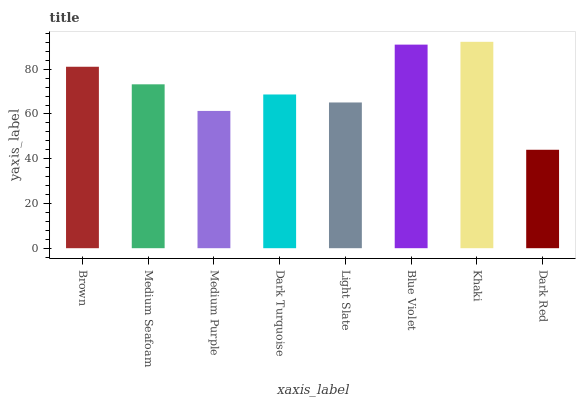Is Dark Red the minimum?
Answer yes or no. Yes. Is Khaki the maximum?
Answer yes or no. Yes. Is Medium Seafoam the minimum?
Answer yes or no. No. Is Medium Seafoam the maximum?
Answer yes or no. No. Is Brown greater than Medium Seafoam?
Answer yes or no. Yes. Is Medium Seafoam less than Brown?
Answer yes or no. Yes. Is Medium Seafoam greater than Brown?
Answer yes or no. No. Is Brown less than Medium Seafoam?
Answer yes or no. No. Is Medium Seafoam the high median?
Answer yes or no. Yes. Is Dark Turquoise the low median?
Answer yes or no. Yes. Is Brown the high median?
Answer yes or no. No. Is Dark Red the low median?
Answer yes or no. No. 